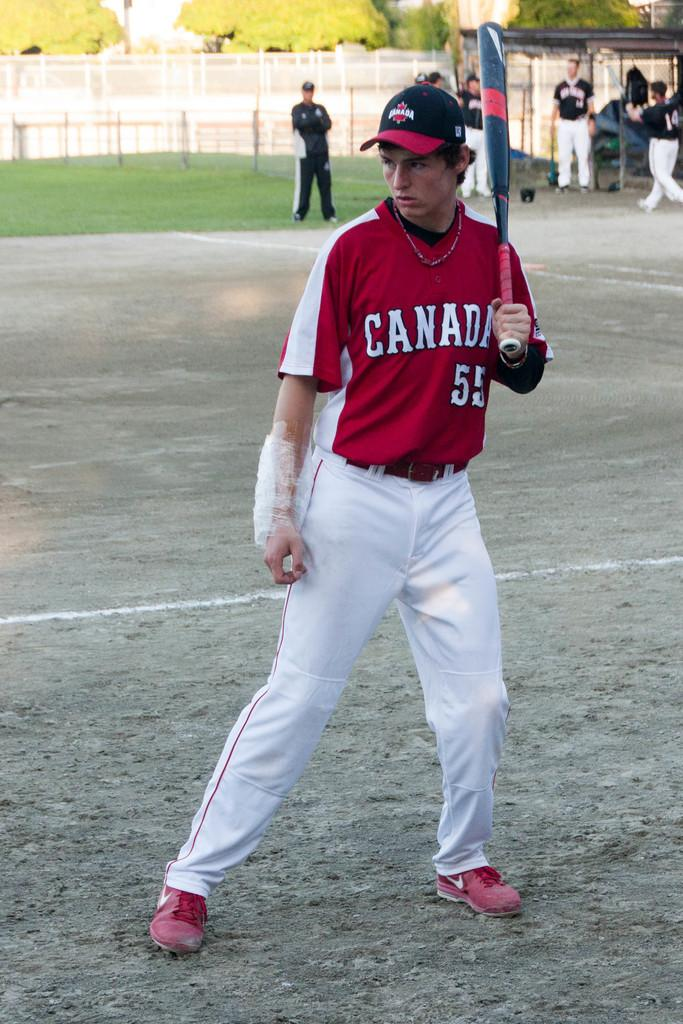<image>
Share a concise interpretation of the image provided. a baseball player wearing a jersey saying canada 